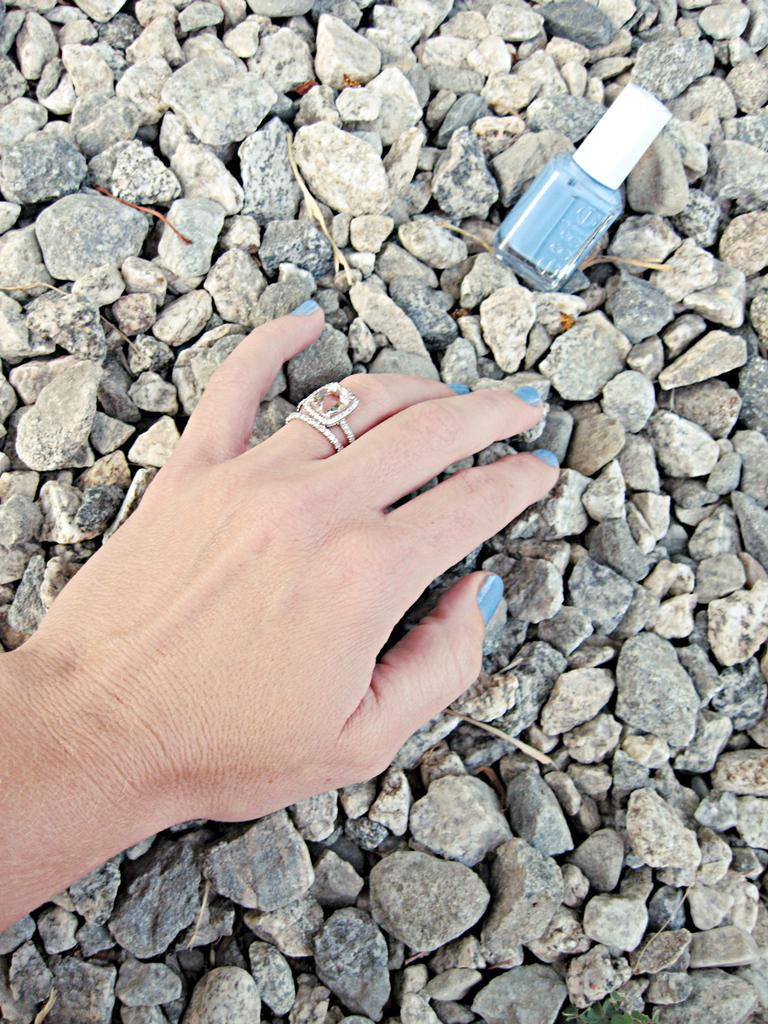What is the person's hand doing in the image? The person's hand is placed on stones in the image. Can you describe any objects in the background of the image? There is a nail polish bottle in the background of the image. How many brothers are visible in the image? There are no brothers present in the image. What type of structure is the person's hand leaning against in the image? The person's hand is placed on stones, not leaning against any structure. 